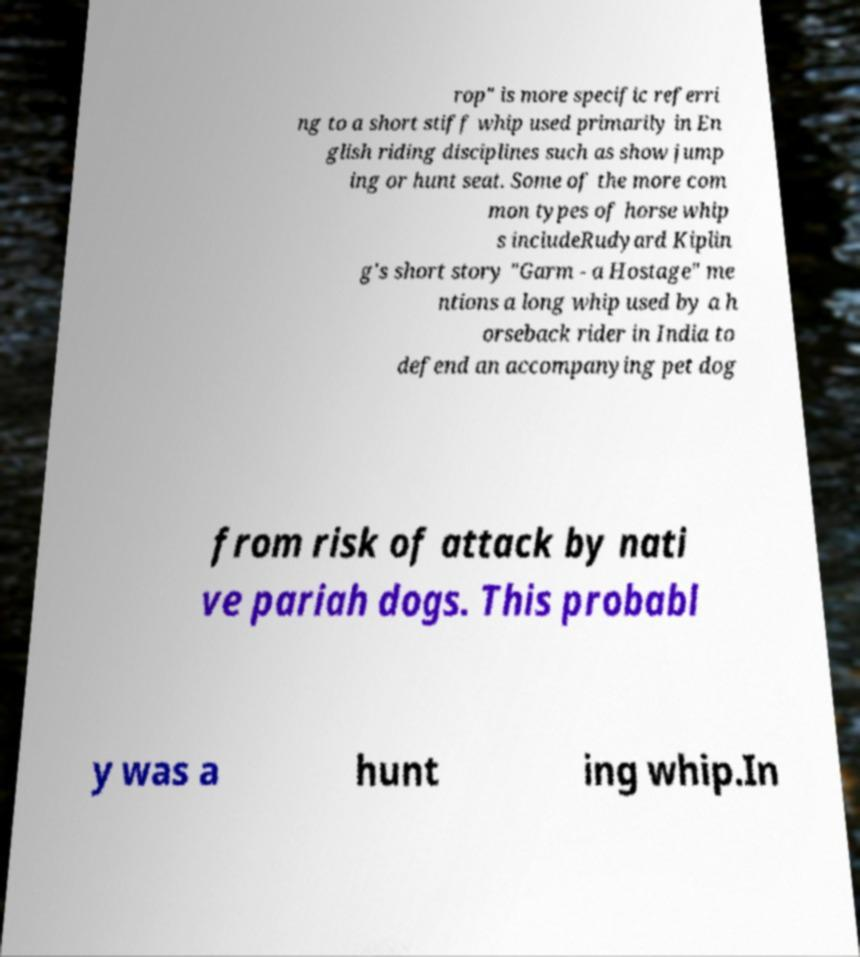There's text embedded in this image that I need extracted. Can you transcribe it verbatim? rop" is more specific referri ng to a short stiff whip used primarily in En glish riding disciplines such as show jump ing or hunt seat. Some of the more com mon types of horse whip s includeRudyard Kiplin g's short story "Garm - a Hostage" me ntions a long whip used by a h orseback rider in India to defend an accompanying pet dog from risk of attack by nati ve pariah dogs. This probabl y was a hunt ing whip.In 